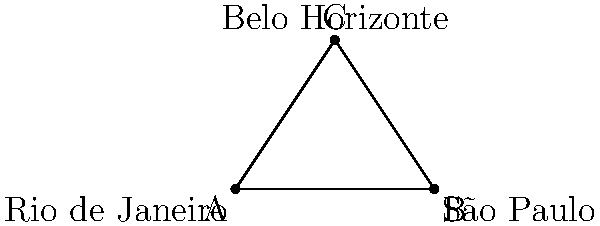On a simplified map of Brazil, three major cities form a triangle: Rio de Janeiro (A), São Paulo (B), and Belo Horizonte (C). The straight-line distances between the cities are: Rio to São Paulo = 8 units, São Paulo to Belo Horizonte = 6 units, and Belo Horizonte to Rio = 6 units. What is the shortest total distance to visit all three cities, starting and ending in Rio de Janeiro? Let's approach this step-by-step:

1) First, we need to understand that the shortest path will always be a combination of straight lines between the cities.

2) There are two possible routes:
   a) Rio → São Paulo → Belo Horizonte → Rio
   b) Rio → Belo Horizonte → São Paulo → Rio

3) Let's calculate the distance for each route:
   
   Route a: 
   Rio to São Paulo = 8 units
   São Paulo to Belo Horizonte = 6 units
   Belo Horizonte to Rio = 6 units
   Total = 8 + 6 + 6 = 20 units

   Route b:
   Rio to Belo Horizonte = 6 units
   Belo Horizonte to São Paulo = 6 units
   São Paulo to Rio = 8 units
   Total = 6 + 6 + 8 = 20 units

4) We can see that both routes have the same total distance of 20 units.

5) Therefore, the shortest total distance to visit all three cities, starting and ending in Rio de Janeiro, is 20 units.
Answer: 20 units 